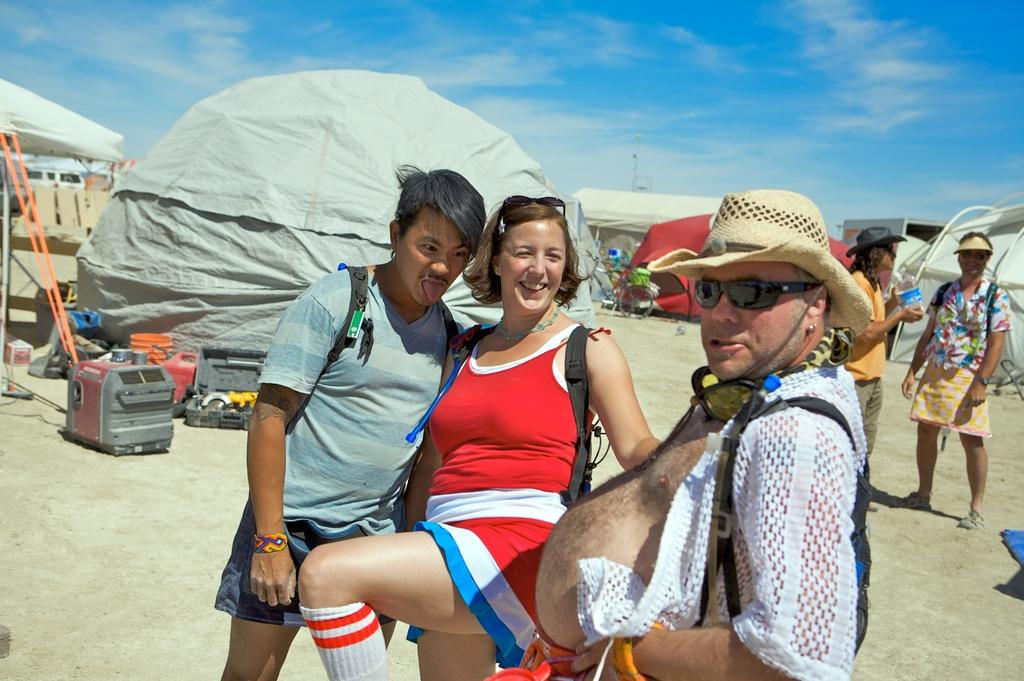What are the people in the image doing? The people are standing in the image. Where are the people located? The people are on a beach. What can be seen in the background of the image? There are tents in the background of the image, and the sky is blue. What type of board is the man holding in the image? There is no board or man holding a board in the image. 